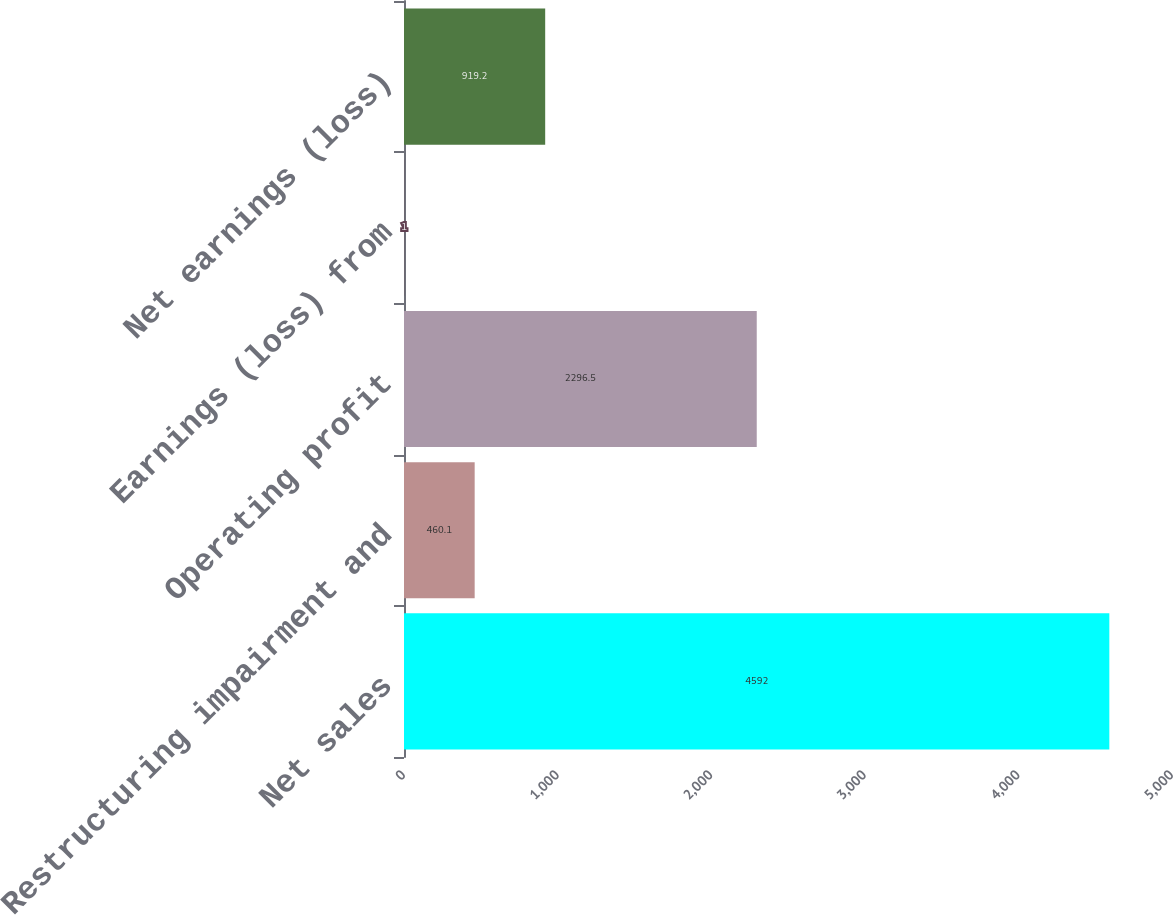<chart> <loc_0><loc_0><loc_500><loc_500><bar_chart><fcel>Net sales<fcel>Restructuring impairment and<fcel>Operating profit<fcel>Earnings (loss) from<fcel>Net earnings (loss)<nl><fcel>4592<fcel>460.1<fcel>2296.5<fcel>1<fcel>919.2<nl></chart> 